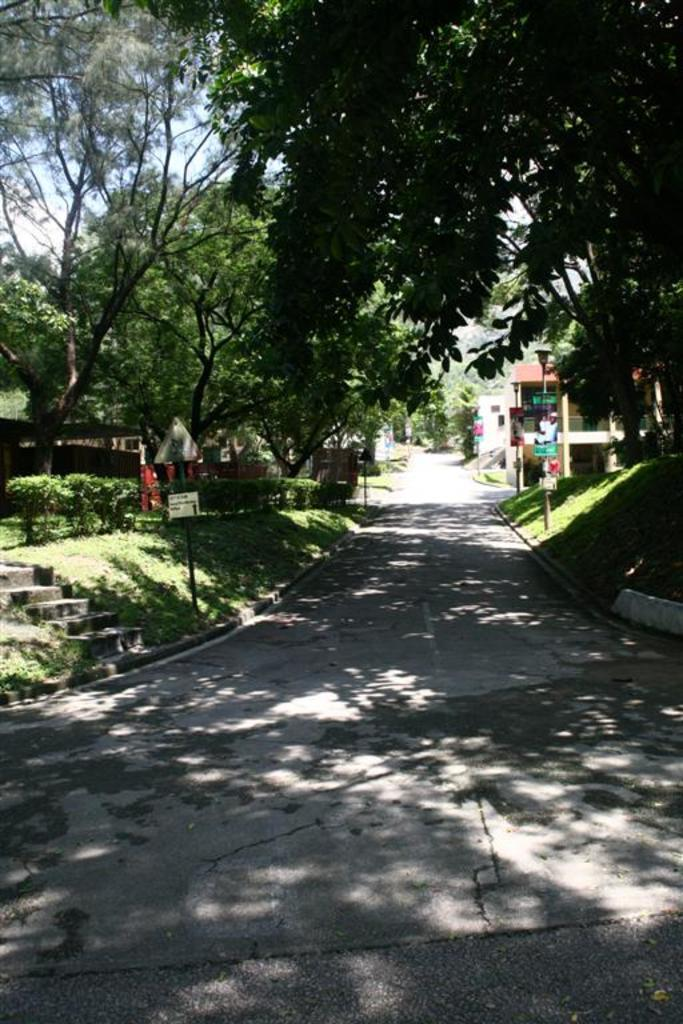What is the main feature in the center of the image? There is a road in the center of the image. What can be seen in the background of the image? The sky, trees, plants, buildings, and grass are visible in the background of the image. Are there any other objects present in the background of the image? Yes, there are a few other objects in the background of the image. What type of spark can be seen coming from the engine in the image? There is no engine present in the image, so it is not possible to determine if there is any spark. 